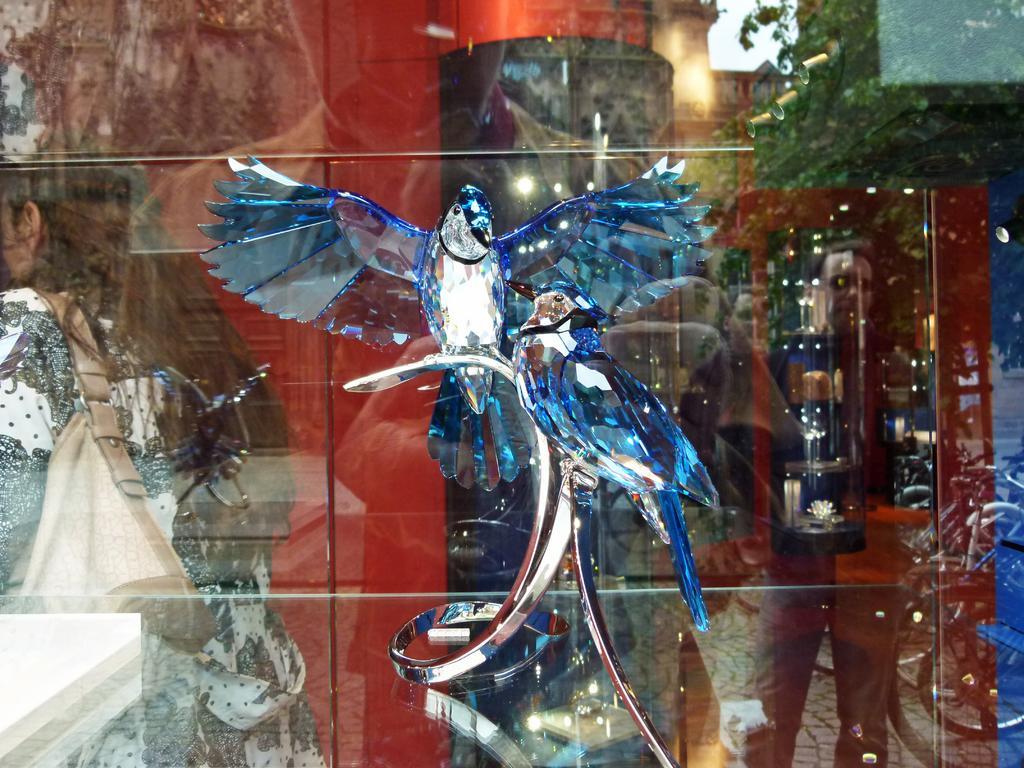How would you summarize this image in a sentence or two? In this image we can see a crystal decorative object. There is a glass wall. On the glass there is a reflection of few people, trees and there is a person wearing a bag. 